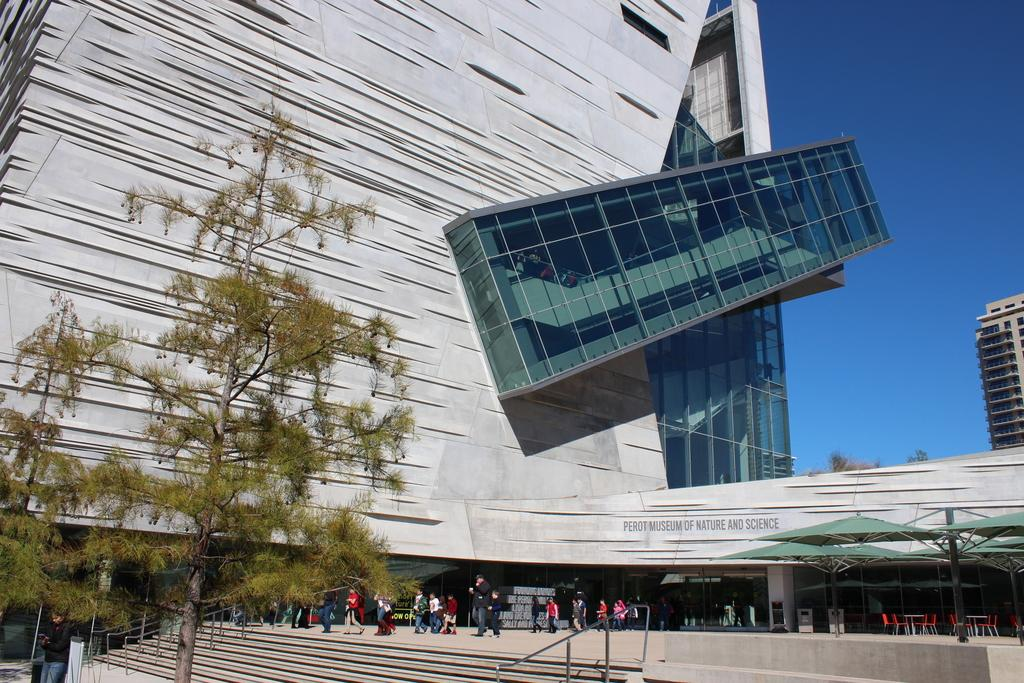What type of structures can be seen in the image? There are buildings in the image. What is located in front of the buildings? There is a path in front of the buildings. What are the people in the image doing? People are walking on the path. What type of vegetation is present in the image? There are trees in the image. What part of the natural environment is visible in the image? The sky is visible in the top right corner of the image. What type of jam is being spread on the bulb in the image? There is no jam or bulb present in the image. How many needles are visible in the image? There are no needles visible in the image. 